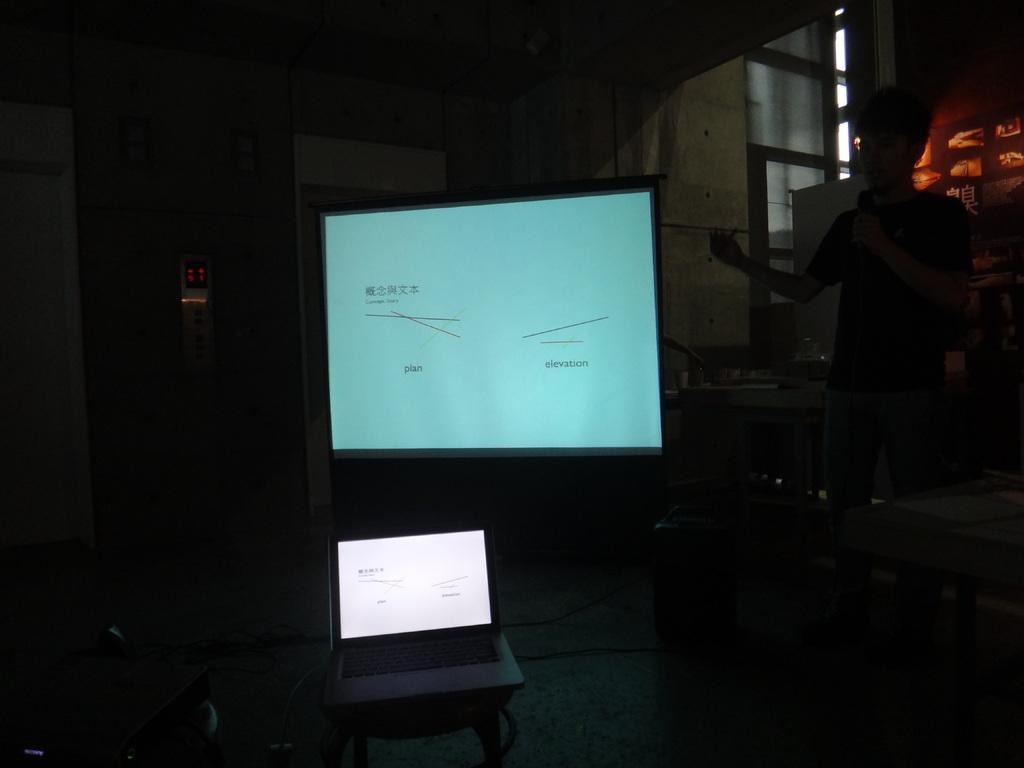Describe this image in one or two sentences. In this image, we can see a person holding a microphone. We can see some screens. We can see the ground with some objects. We can also see the wall with some objects. We can also see some wires and an object on the bottom left corner. 